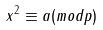Convert formula to latex. <formula><loc_0><loc_0><loc_500><loc_500>x ^ { 2 } \equiv a ( m o d p )</formula> 